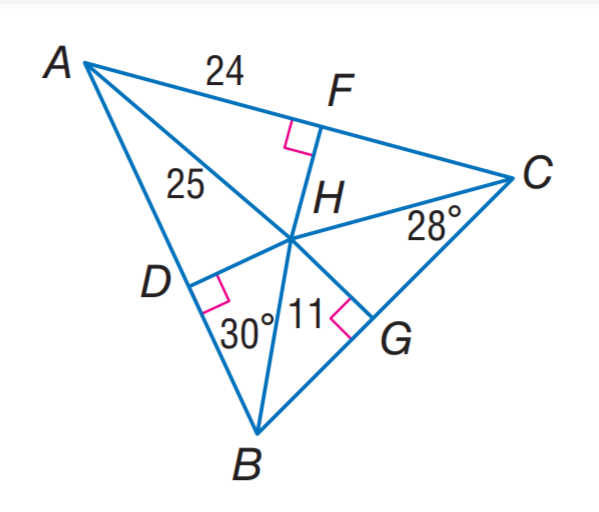Answer the mathemtical geometry problem and directly provide the correct option letter.
Question: H is the incenter of \triangle A B C. Find B D.
Choices: A: \frac { 7 } { \sqrt 3 } B: 7 C: 7 \sqrt 3 D: 14 C 